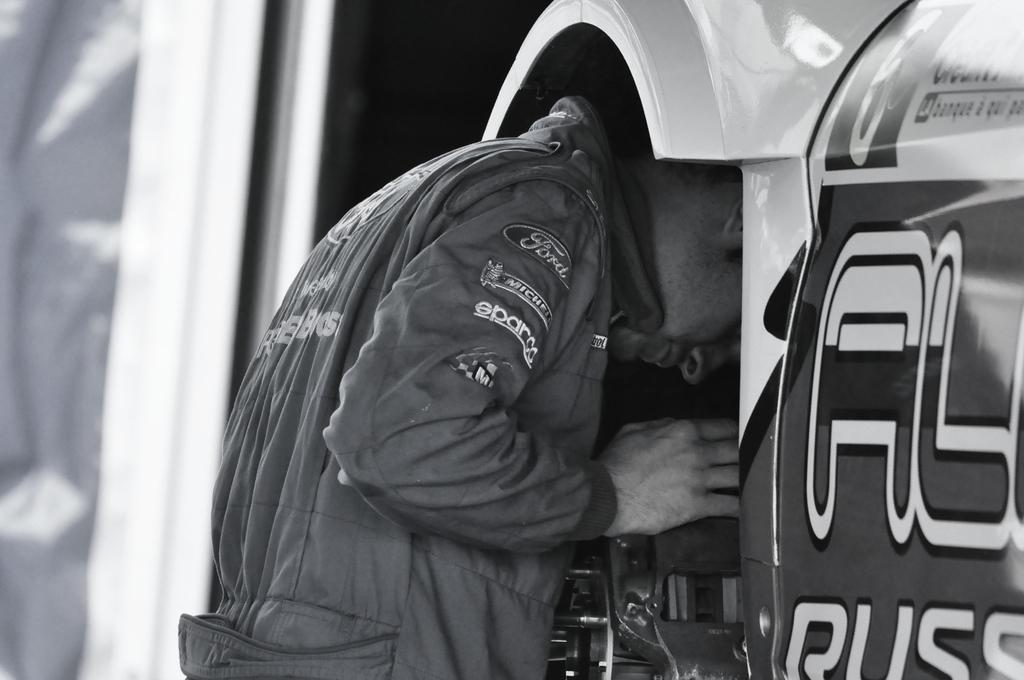What is the main subject in the foreground of the image? There is a man in the foreground of the image. What is the man wearing in the image? The man is wearing a jacket. What is the man doing in the image? The man is inserting his head into an object. How does the man grip the flock of birds in the image? There are no birds present in the image, so the man cannot grip a flock of birds. 